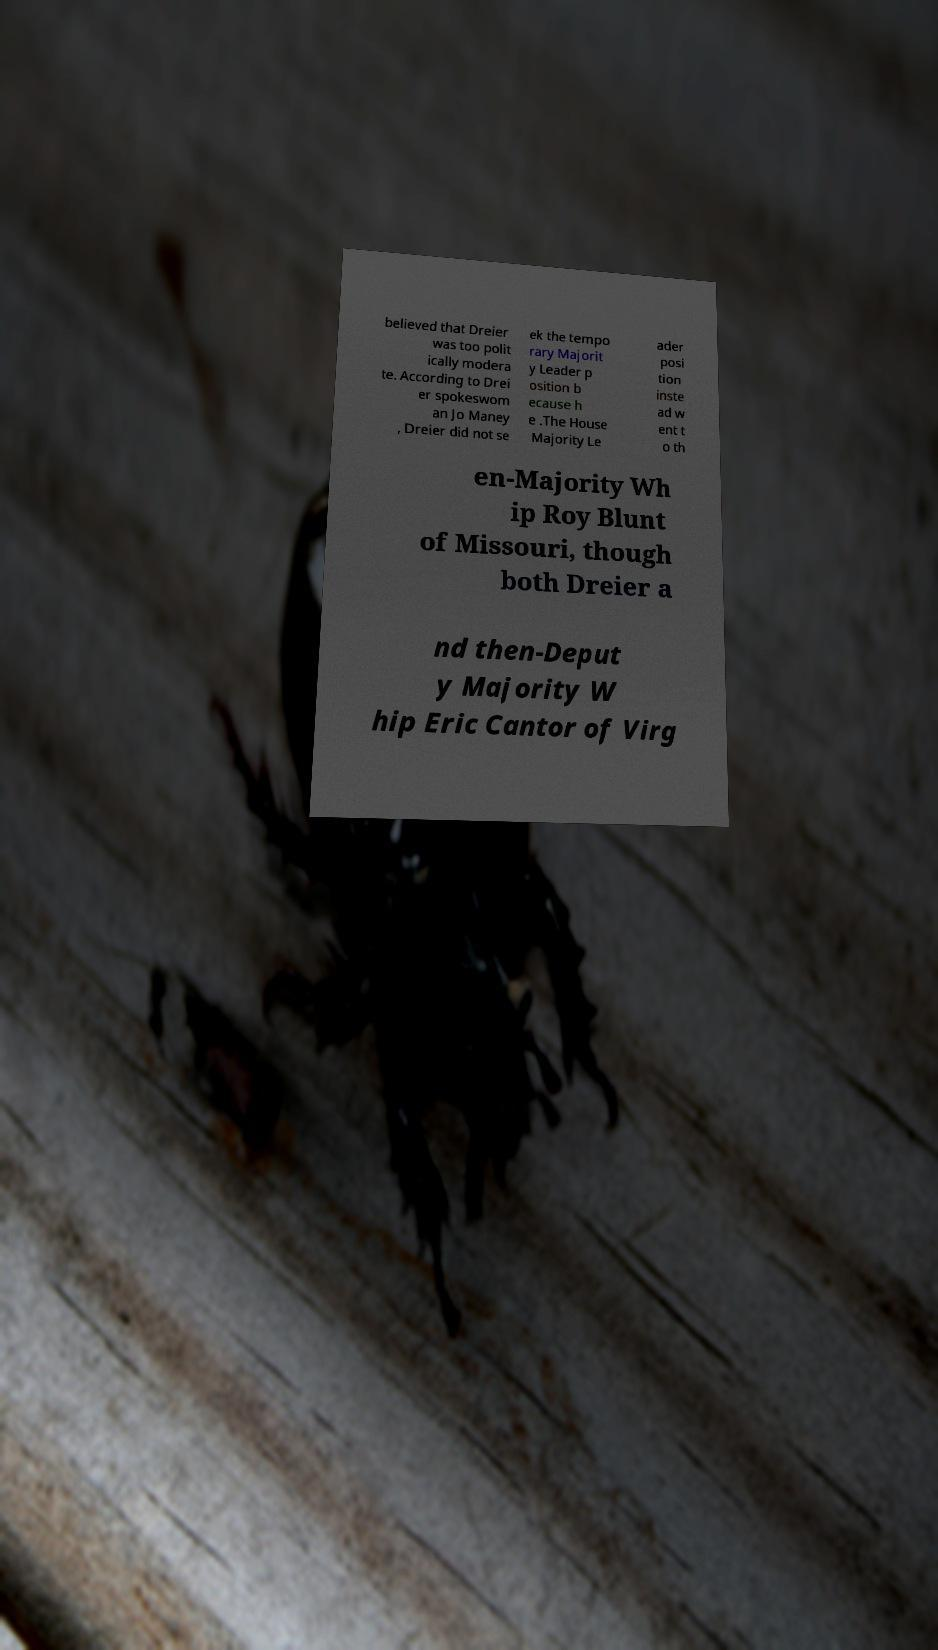There's text embedded in this image that I need extracted. Can you transcribe it verbatim? believed that Dreier was too polit ically modera te. According to Drei er spokeswom an Jo Maney , Dreier did not se ek the tempo rary Majorit y Leader p osition b ecause h e .The House Majority Le ader posi tion inste ad w ent t o th en-Majority Wh ip Roy Blunt of Missouri, though both Dreier a nd then-Deput y Majority W hip Eric Cantor of Virg 